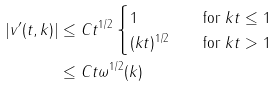<formula> <loc_0><loc_0><loc_500><loc_500>| v ^ { \prime } ( t , k ) | & \leq C t ^ { 1 / 2 } \begin{cases} 1 & \quad \text {for } k t \leq 1 \\ ( k t ) ^ { 1 / 2 } & \quad \text {for } k t > 1 \end{cases} \\ & \leq C t \omega ^ { 1 / 2 } ( k ) \\</formula> 